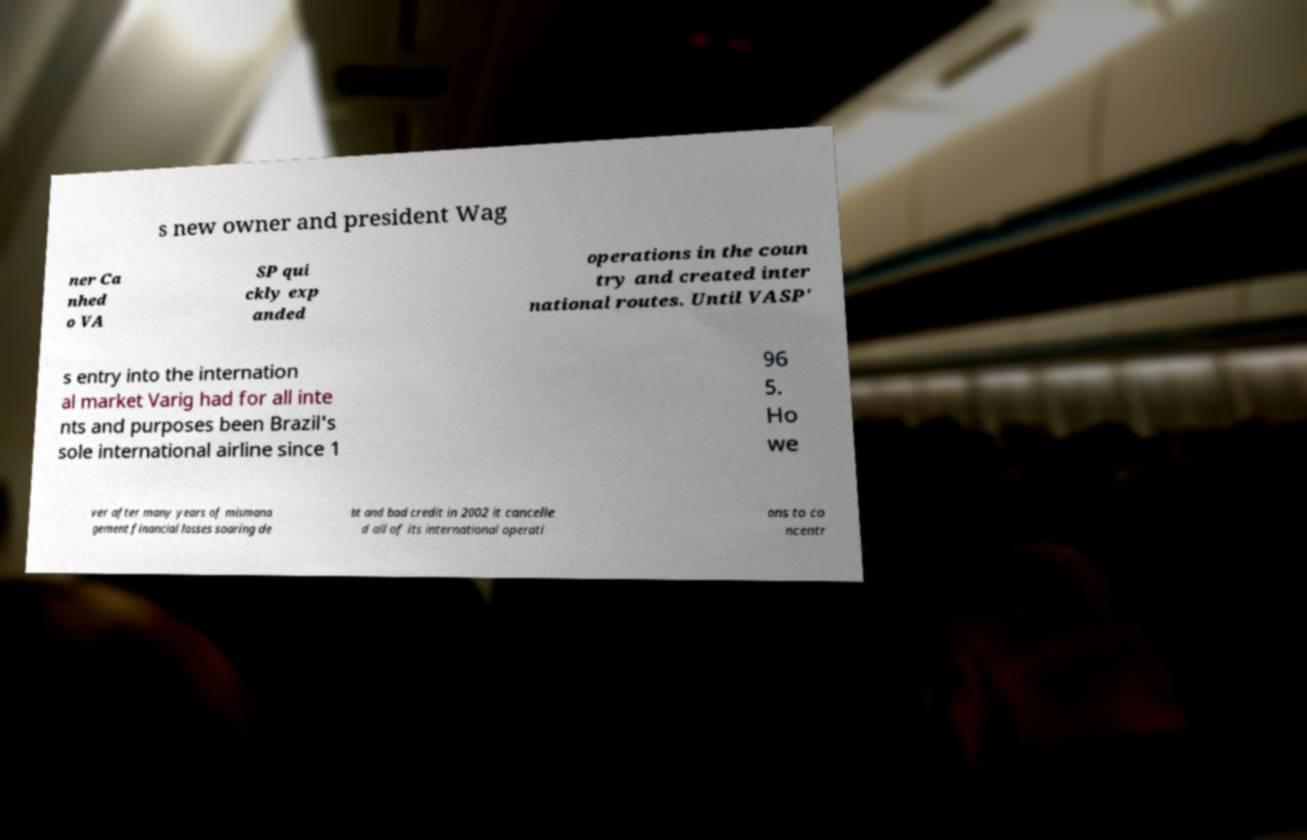Could you assist in decoding the text presented in this image and type it out clearly? s new owner and president Wag ner Ca nhed o VA SP qui ckly exp anded operations in the coun try and created inter national routes. Until VASP' s entry into the internation al market Varig had for all inte nts and purposes been Brazil's sole international airline since 1 96 5. Ho we ver after many years of mismana gement financial losses soaring de bt and bad credit in 2002 it cancelle d all of its international operati ons to co ncentr 